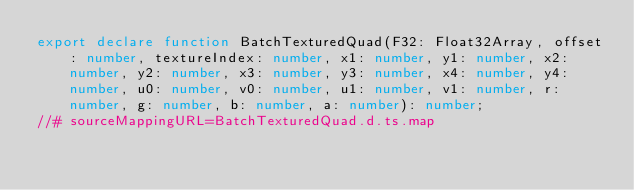<code> <loc_0><loc_0><loc_500><loc_500><_TypeScript_>export declare function BatchTexturedQuad(F32: Float32Array, offset: number, textureIndex: number, x1: number, y1: number, x2: number, y2: number, x3: number, y3: number, x4: number, y4: number, u0: number, v0: number, u1: number, v1: number, r: number, g: number, b: number, a: number): number;
//# sourceMappingURL=BatchTexturedQuad.d.ts.map</code> 